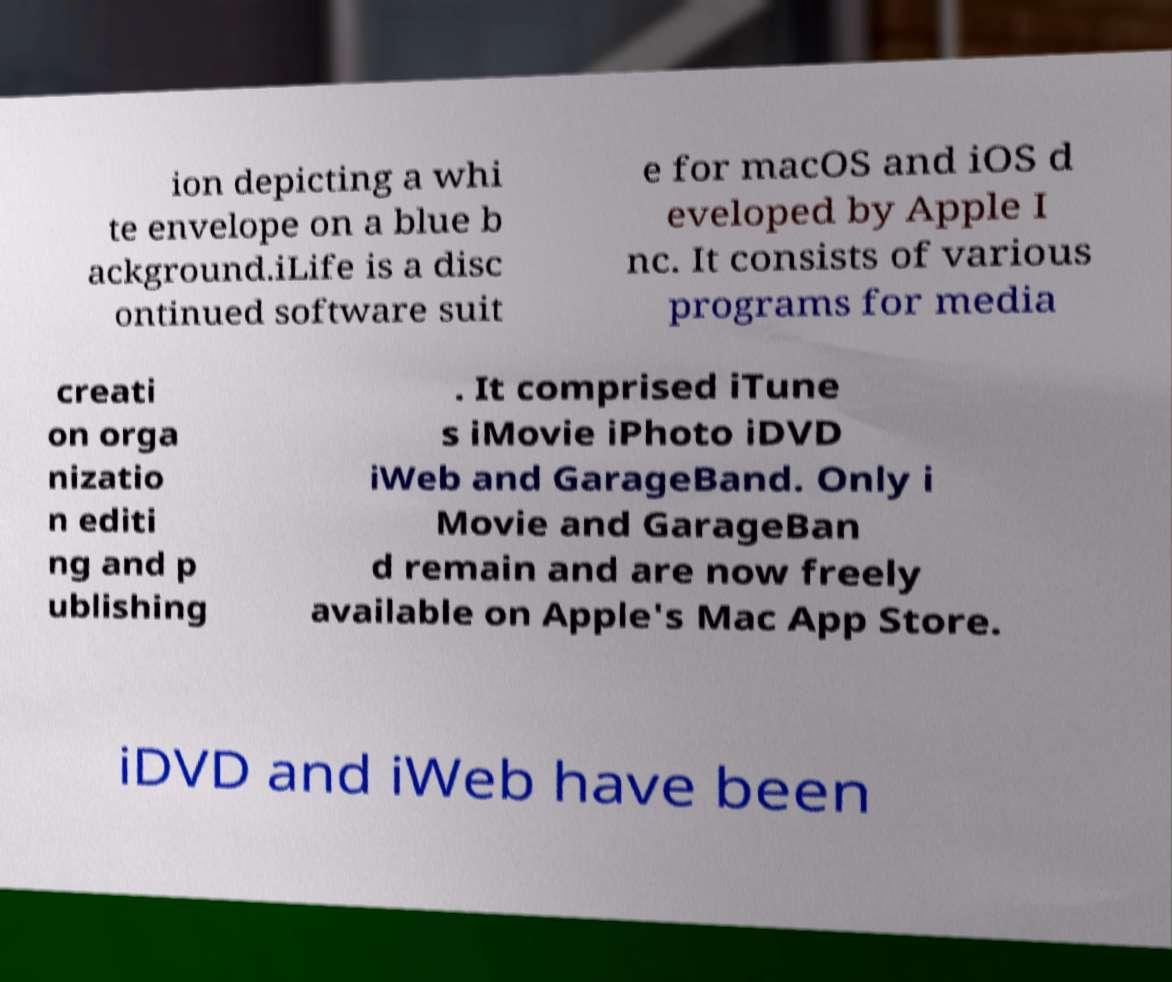Could you assist in decoding the text presented in this image and type it out clearly? ion depicting a whi te envelope on a blue b ackground.iLife is a disc ontinued software suit e for macOS and iOS d eveloped by Apple I nc. It consists of various programs for media creati on orga nizatio n editi ng and p ublishing . It comprised iTune s iMovie iPhoto iDVD iWeb and GarageBand. Only i Movie and GarageBan d remain and are now freely available on Apple's Mac App Store. iDVD and iWeb have been 